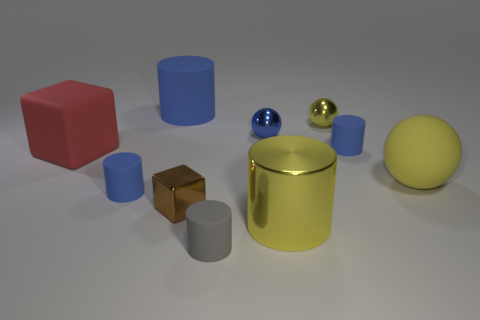Subtract all cyan balls. How many blue cylinders are left? 3 Subtract all metallic cylinders. How many cylinders are left? 4 Subtract all gray cylinders. How many cylinders are left? 4 Subtract 2 cylinders. How many cylinders are left? 3 Subtract all brown cylinders. Subtract all gray spheres. How many cylinders are left? 5 Subtract all cubes. How many objects are left? 8 Add 9 red matte cubes. How many red matte cubes are left? 10 Add 7 large yellow balls. How many large yellow balls exist? 8 Subtract 0 green cylinders. How many objects are left? 10 Subtract all tiny brown objects. Subtract all large yellow spheres. How many objects are left? 8 